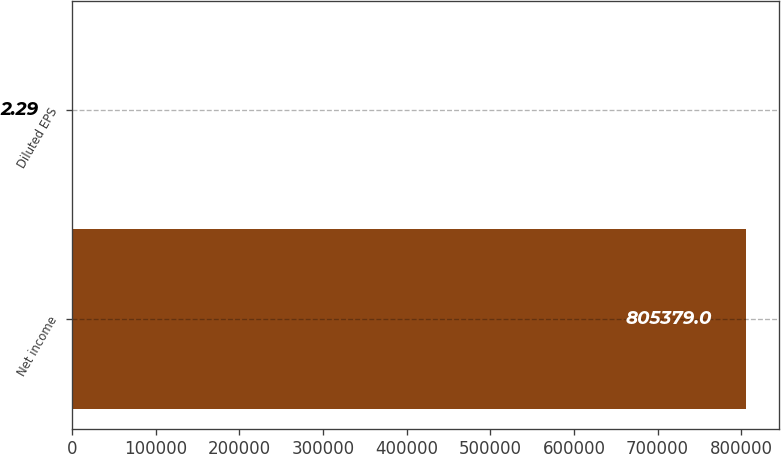Convert chart to OTSL. <chart><loc_0><loc_0><loc_500><loc_500><bar_chart><fcel>Net income<fcel>Diluted EPS<nl><fcel>805379<fcel>2.29<nl></chart> 